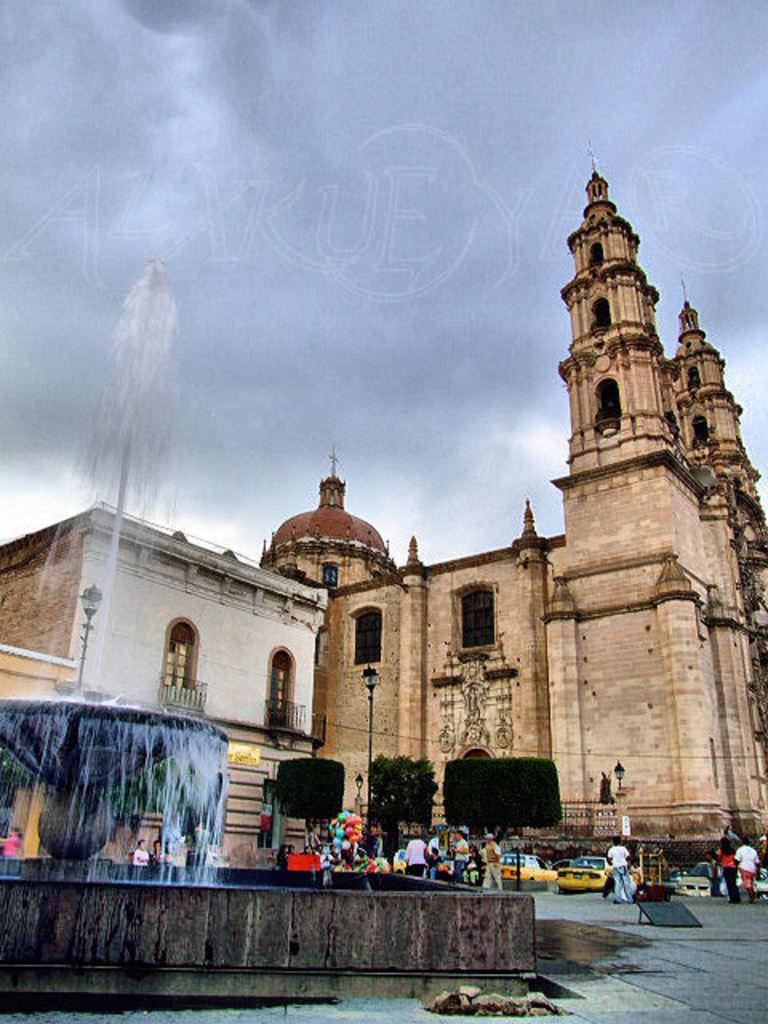What natural feature is located on the left side of the image? There is a waterfall on the left side of the image. What can be seen in the middle of the image? There are people and vehicles on the road, as well as a big fort. What is the condition of the sky in the image? The sky is cloudy at the top of the image. Can you tell me how many strangers are visible in the image? There is no mention of strangers in the image, so it is not possible to determine their presence or number. What type of pest can be seen crawling on the fort in the image? There is no pest visible in the image, as it features a waterfall, people, vehicles, and a fort. 